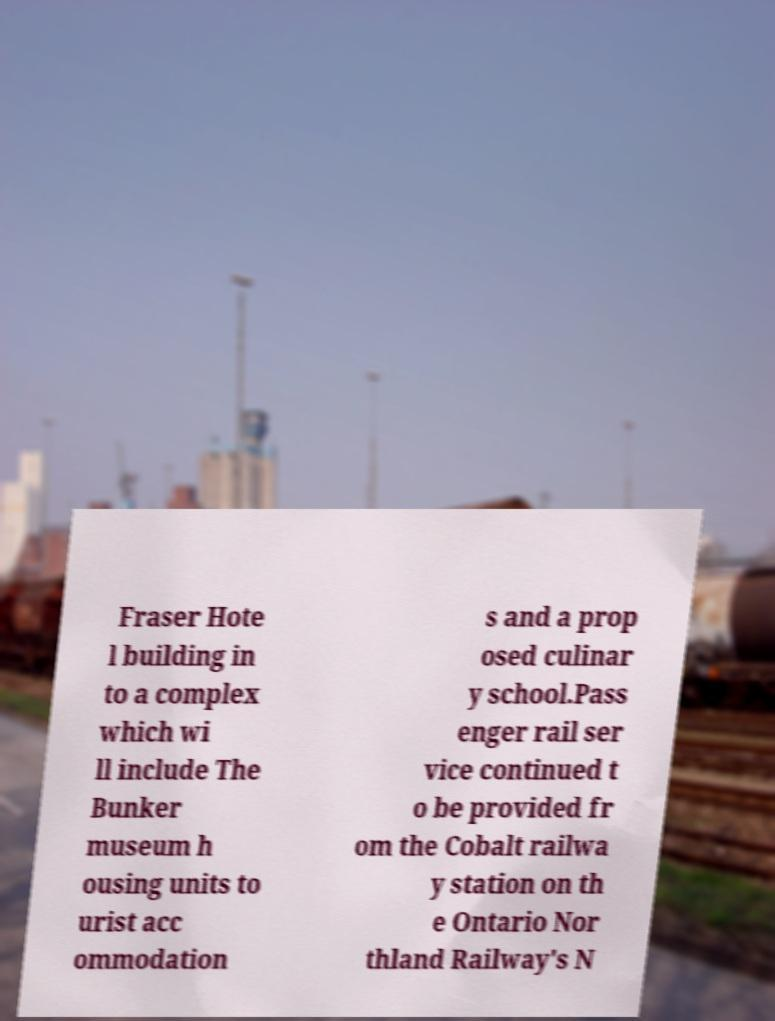Could you extract and type out the text from this image? Fraser Hote l building in to a complex which wi ll include The Bunker museum h ousing units to urist acc ommodation s and a prop osed culinar y school.Pass enger rail ser vice continued t o be provided fr om the Cobalt railwa y station on th e Ontario Nor thland Railway's N 